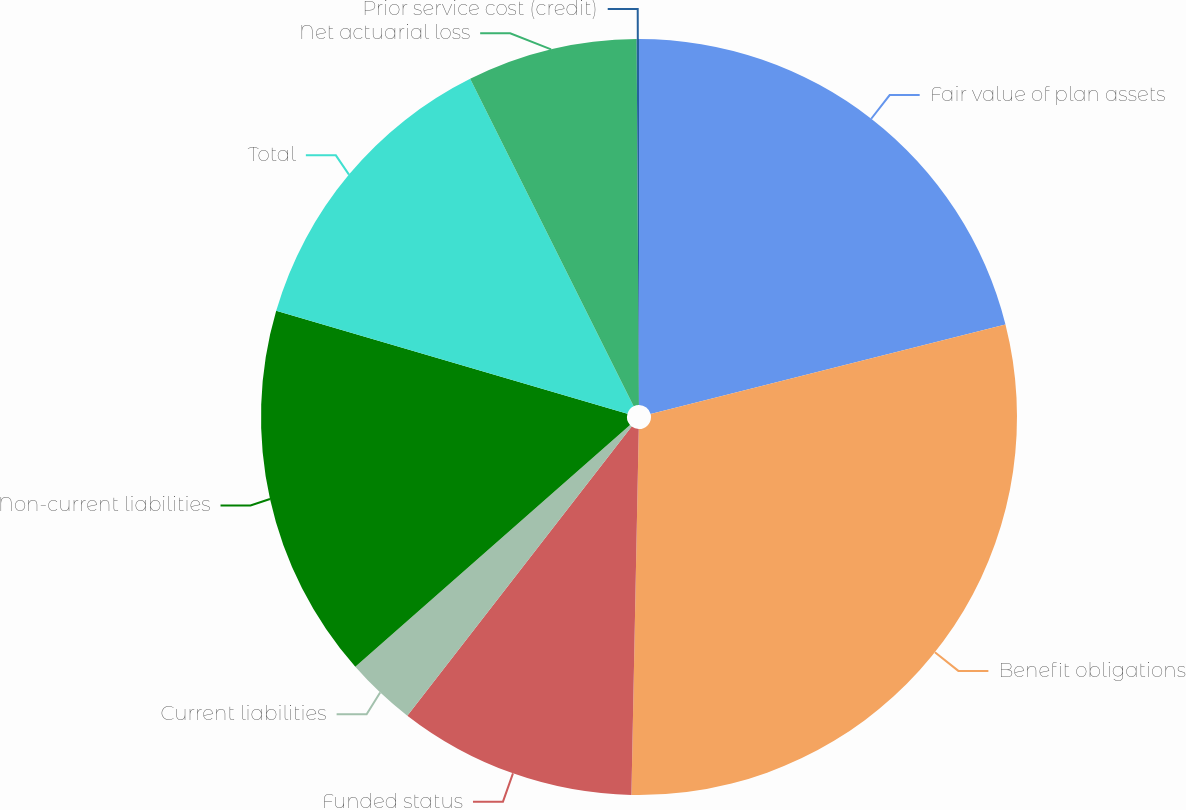<chart> <loc_0><loc_0><loc_500><loc_500><pie_chart><fcel>Fair value of plan assets<fcel>Benefit obligations<fcel>Funded status<fcel>Current liabilities<fcel>Non-current liabilities<fcel>Total<fcel>Net actuarial loss<fcel>Prior service cost (credit)<nl><fcel>21.06%<fcel>29.26%<fcel>10.18%<fcel>3.01%<fcel>16.02%<fcel>13.1%<fcel>7.27%<fcel>0.1%<nl></chart> 